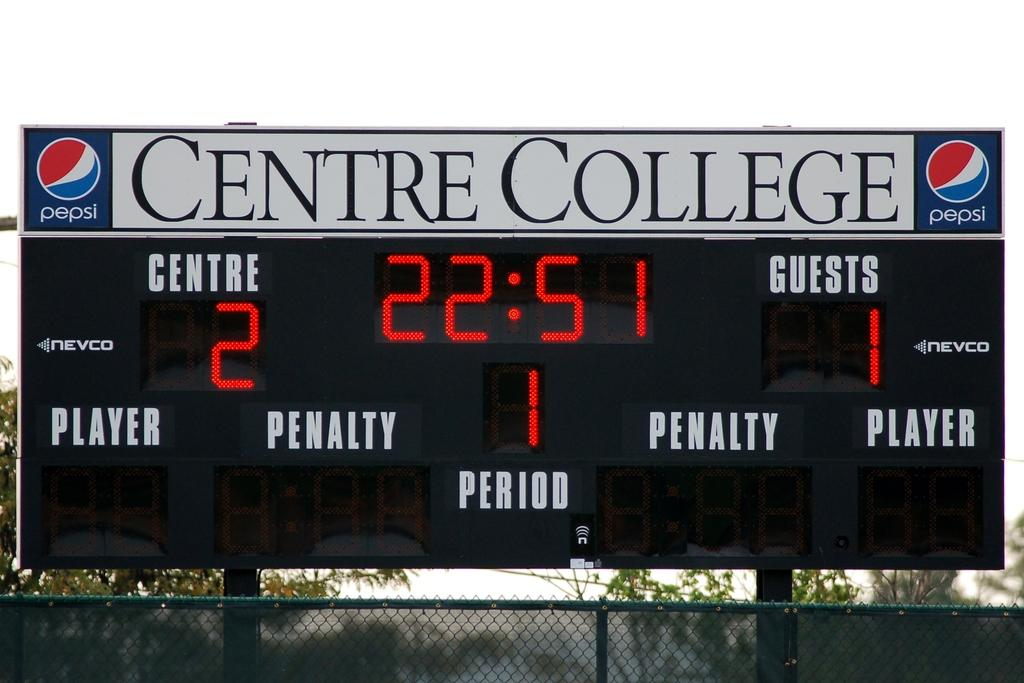<image>
Offer a succinct explanation of the picture presented. Scoreboard for Centre College which has a Pepsi ad. 